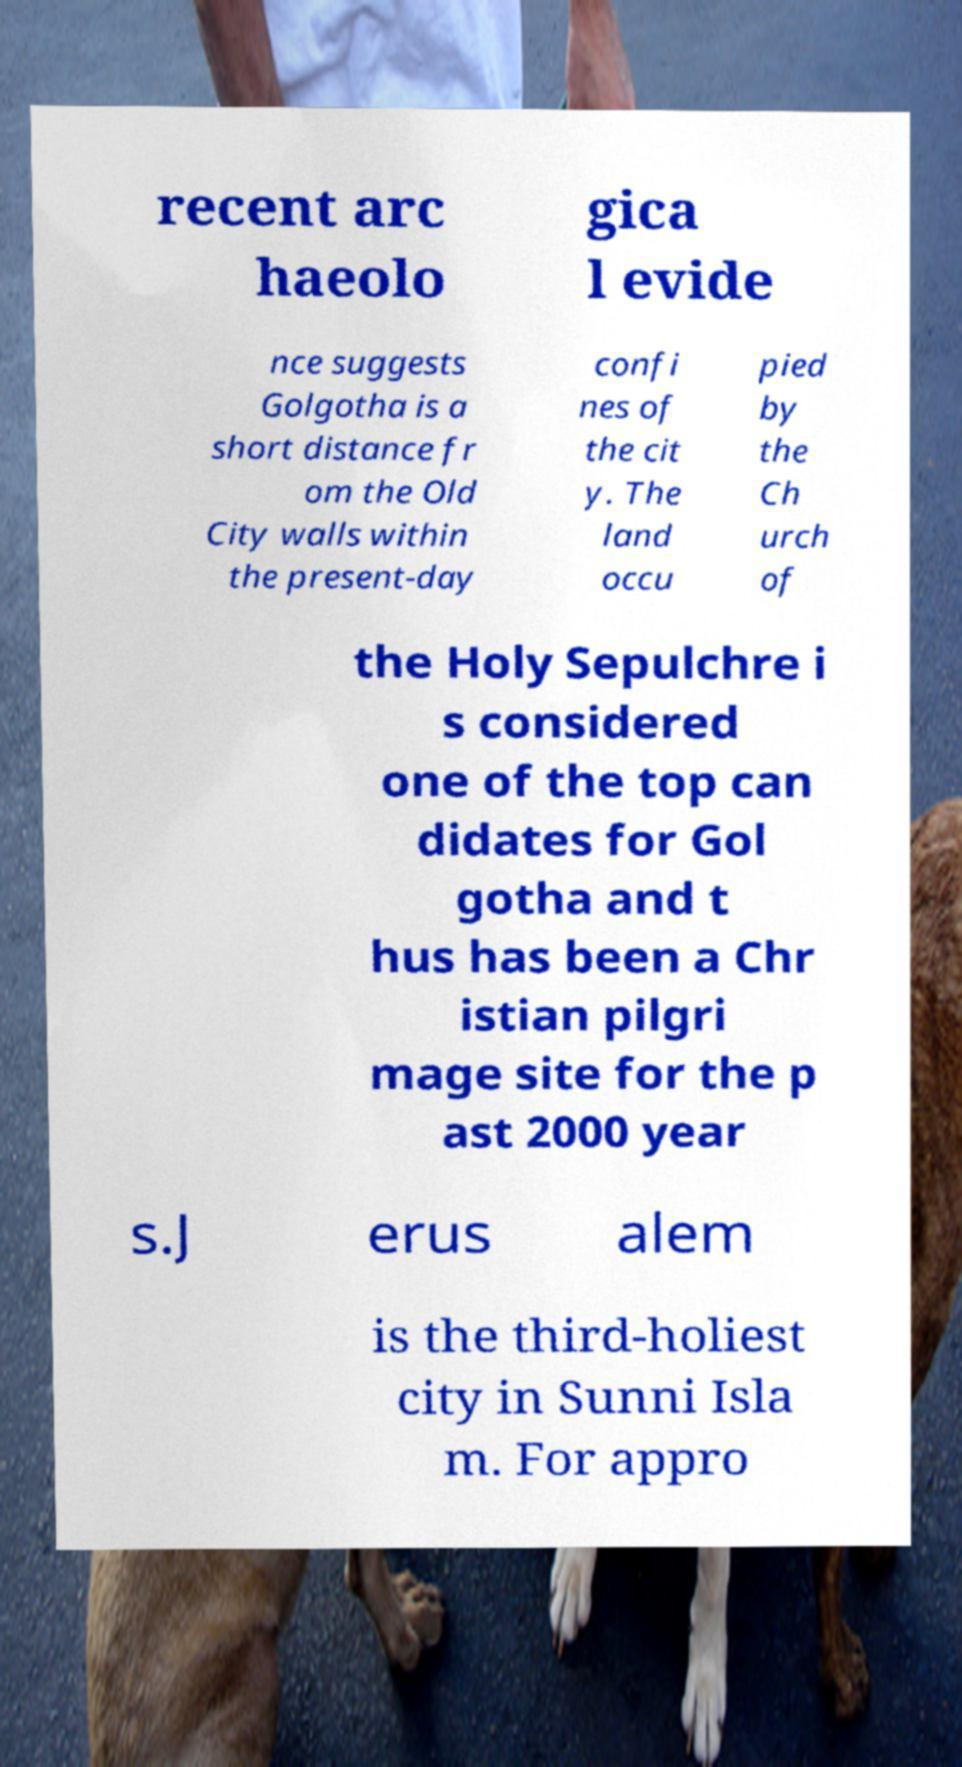Please identify and transcribe the text found in this image. recent arc haeolo gica l evide nce suggests Golgotha is a short distance fr om the Old City walls within the present-day confi nes of the cit y. The land occu pied by the Ch urch of the Holy Sepulchre i s considered one of the top can didates for Gol gotha and t hus has been a Chr istian pilgri mage site for the p ast 2000 year s.J erus alem is the third-holiest city in Sunni Isla m. For appro 